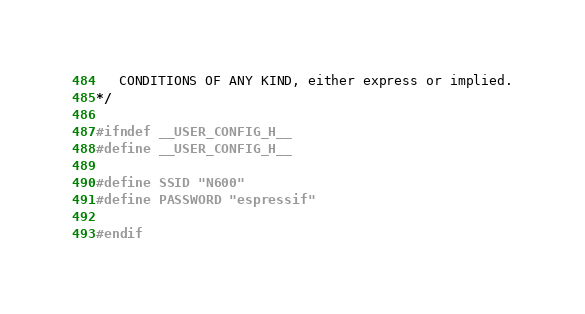<code> <loc_0><loc_0><loc_500><loc_500><_C_>   CONDITIONS OF ANY KIND, either express or implied.
*/

#ifndef __USER_CONFIG_H__
#define __USER_CONFIG_H__

#define SSID "N600"
#define PASSWORD "espressif"

#endif

</code> 